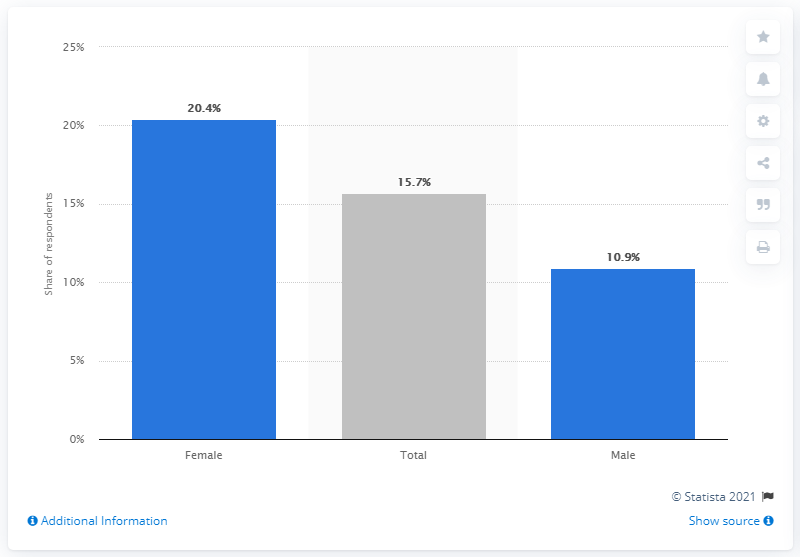Indicate a few pertinent items in this graphic. In the period between August 2018 and June 2019, 15.7% of high school students reported experiencing cyberbullying. 